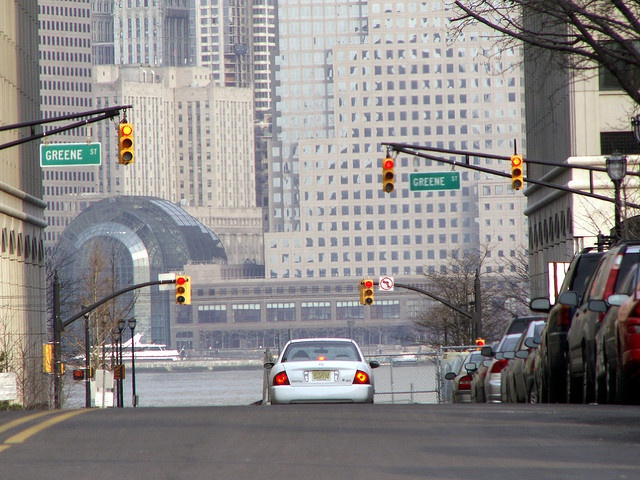Describe the objects in this image and their specific colors. I can see car in tan, lightgray, darkgray, and gray tones, car in tan, black, gray, maroon, and darkgray tones, car in tan, black, gray, and maroon tones, car in tan, black, gray, and maroon tones, and boat in tan, white, darkgray, and gray tones in this image. 